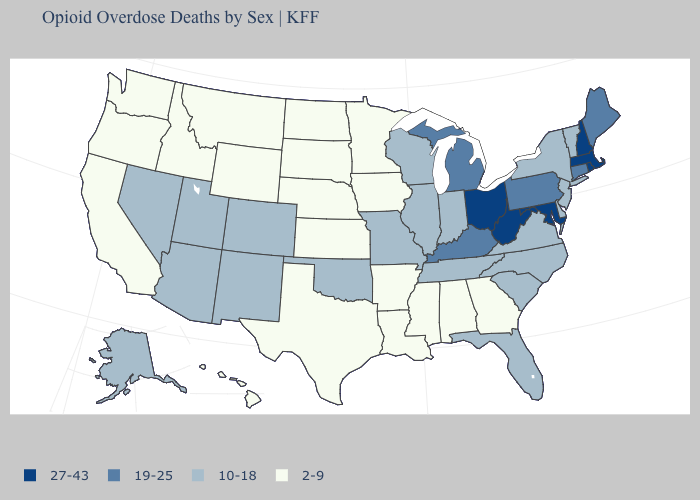Does Louisiana have the lowest value in the South?
Keep it brief. Yes. What is the value of Missouri?
Be succinct. 10-18. How many symbols are there in the legend?
Short answer required. 4. Among the states that border Idaho , does Washington have the lowest value?
Keep it brief. Yes. How many symbols are there in the legend?
Keep it brief. 4. Does the map have missing data?
Write a very short answer. No. What is the value of Alabama?
Quick response, please. 2-9. What is the value of Alabama?
Concise answer only. 2-9. Among the states that border Vermont , which have the lowest value?
Answer briefly. New York. Which states hav the highest value in the Northeast?
Write a very short answer. Massachusetts, New Hampshire, Rhode Island. Name the states that have a value in the range 19-25?
Short answer required. Connecticut, Kentucky, Maine, Michigan, Pennsylvania. What is the highest value in the West ?
Quick response, please. 10-18. Which states have the highest value in the USA?
Give a very brief answer. Maryland, Massachusetts, New Hampshire, Ohio, Rhode Island, West Virginia. What is the value of Minnesota?
Give a very brief answer. 2-9. What is the value of Wisconsin?
Be succinct. 10-18. 